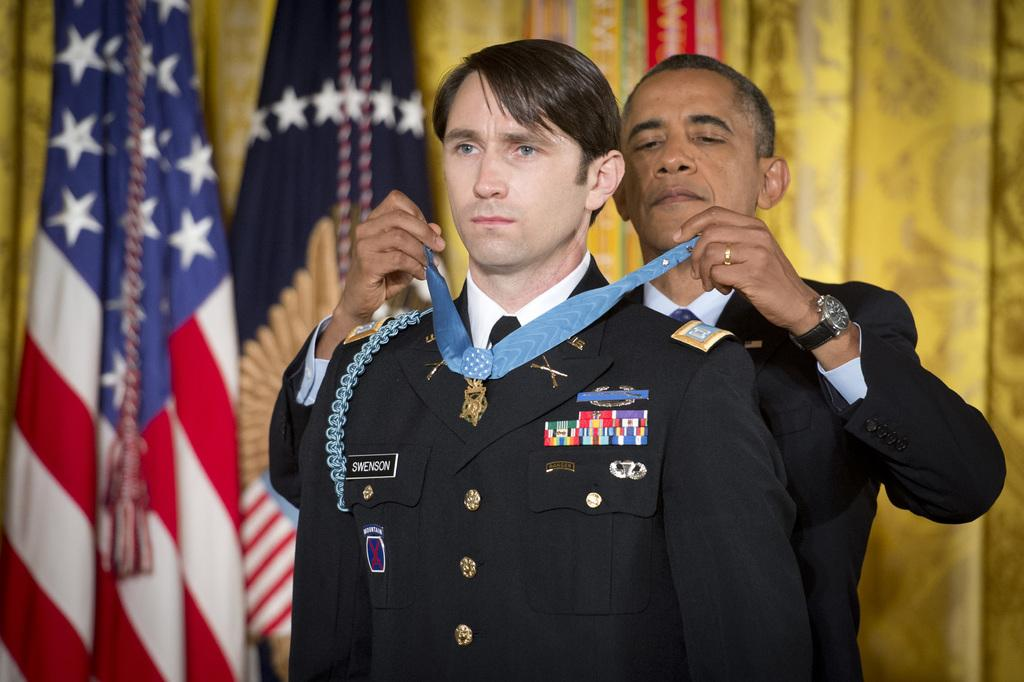Provide a one-sentence caption for the provided image. President Obama placing an award around service man named Swenson. 